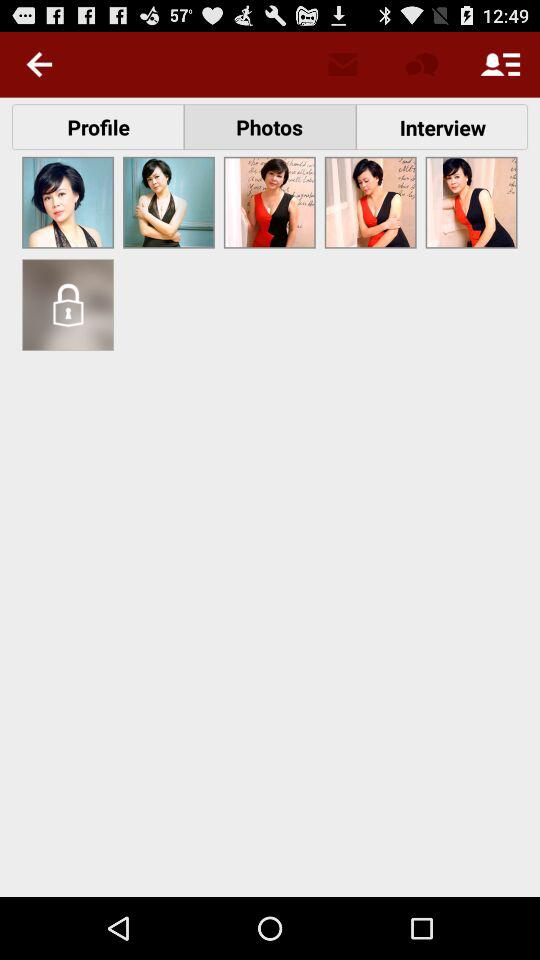Which tab is selected? The selected tab is "Photos". 